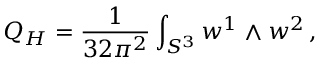<formula> <loc_0><loc_0><loc_500><loc_500>Q _ { H } = \frac { 1 } { 3 2 \pi ^ { 2 } } \int _ { S ^ { 3 } } w ^ { 1 } \wedge w ^ { 2 } \, ,</formula> 